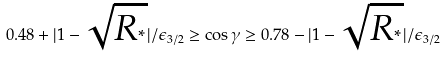<formula> <loc_0><loc_0><loc_500><loc_500>0 . 4 8 + | 1 - \sqrt { R _ { ^ { * } } } | / \epsilon _ { 3 / 2 } \geq \cos \gamma \geq 0 . 7 8 - | 1 - \sqrt { R _ { ^ { * } } } | / \epsilon _ { 3 / 2 }</formula> 